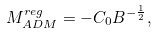<formula> <loc_0><loc_0><loc_500><loc_500>M _ { A D M } ^ { r e g } = - C _ { 0 } B ^ { - \frac { 1 } { 2 } } ,</formula> 